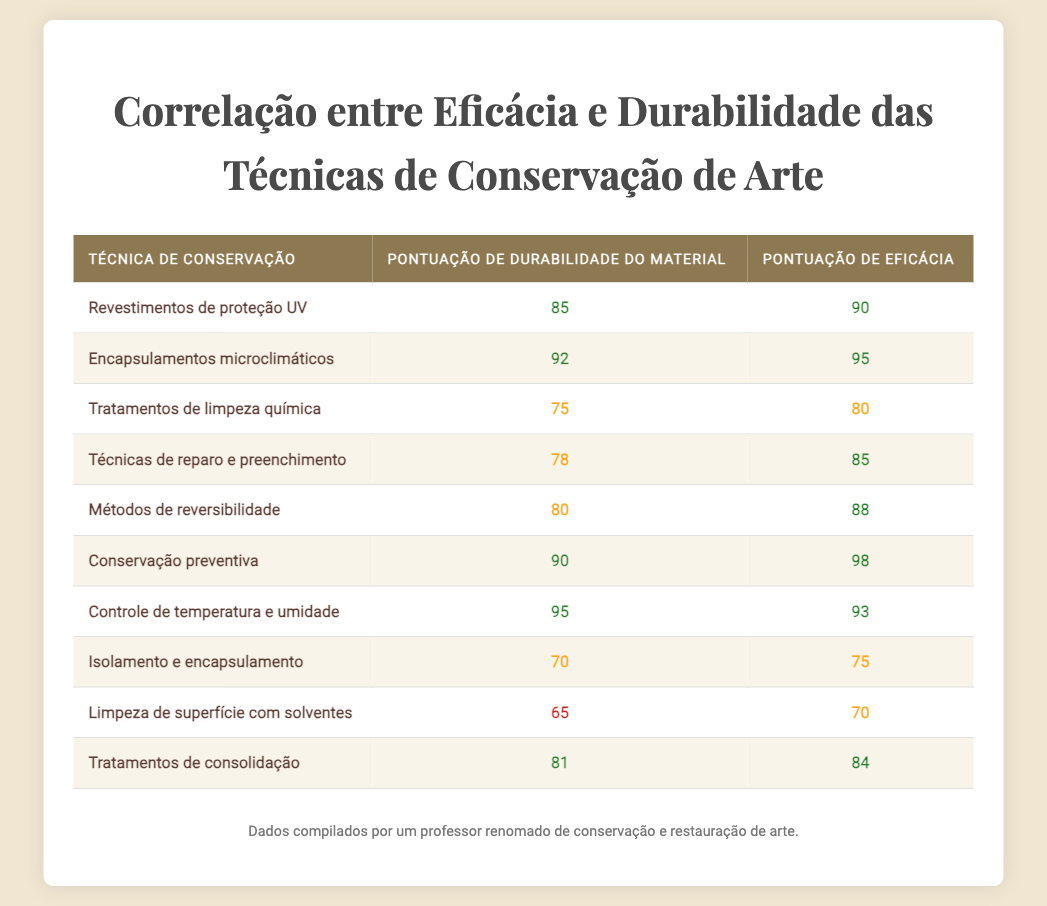Qual é a pontuação de eficácia das "Técnicas de reparo e preenchimento"? A pontuação de eficácia das "Técnicas de reparo e preenchimento" é encontrada na tabela na linha correspondente, que mostra 85.
Answer: 85 Qual técnica de conservação tem a maior pontuação de durabilidade do material? A maior pontuação de durabilidade do material é 95, que corresponde à técnica "Controle de temperatura e umidade".
Answer: Controle de temperatura e umidade Qual é a diferença entre a pontuação de eficácia da "Conservação preventiva" e a "Limpeza de superfície com solventes"? A pontuação de eficácia da "Conservação preventiva" é 98 e a da "Limpeza de superfície com solventes" é 70. Portanto, a diferença é 98 - 70 = 28.
Answer: 28 As "Tratamentos de consolidação" têm uma pontuação de durabilidade do material acima de 80? A pontuação de durabilidade do material das "Tratamentos de consolidação" é 81, que é maior que 80, portanto a afirmação é verdadeira.
Answer: Sim Qual técnica apresenta o menor valor de eficácia entre as listadas? Ao examinar as pontuações de eficácia, "Limpeza de superfície com solventes" tem a menor pontuação com 70.
Answer: Limpeza de superfície com solventes Qual é a média das pontuações de eficácia para as técnicas de conservação na tabela? Para calcular a média, somamos todas as pontuações de eficácia: (90 + 95 + 80 + 85 + 88 + 98 + 93 + 75 + 70 + 84) =  90.5 e então dividimos pelo número de técnicas, 10, resultando em uma média de 87.5.
Answer: 87.5 As "Microclimate enclosures" são mais eficazes do que "Isolation and encapsulation"? Comparando as pontuações, "Microclimate enclosures" tem uma pontuação de eficácia de 95 enquanto "Isolation and encapsulation" tem 75. Portanto, "Microclimate enclosures" é mais eficaz.
Answer: Sim Qual técnica tem pontuação de durabilidade do material e eficácia que totalizam mais de 180? A técnica "Conservação preventiva" tem uma pontuação de durabilidade de 90 e uma eficácia de 98, totalizando 188, o que é maior que 180.
Answer: Conservação preventiva Qual é a menor pontuação de durabilidade do material entre as técnicas de conservação? A menor pontuação de durabilidade do material é 65, encontrada na técnica "Limpeza de superfície com solventes".
Answer: Limpeza de superfície com solventes 